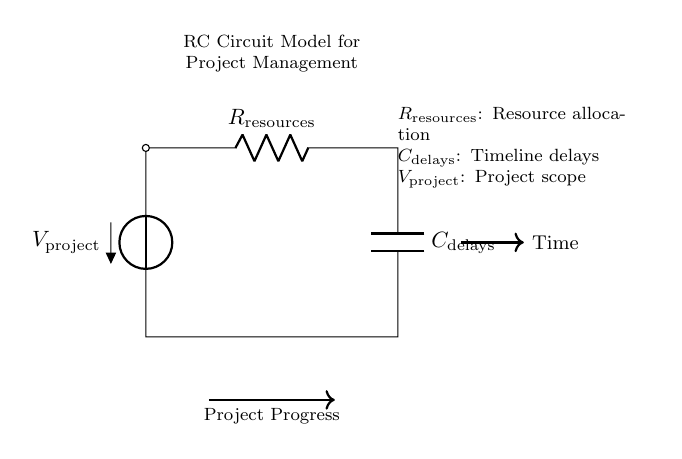What does the resistor represent in this circuit? The resistor represents resource allocation, indicating the amount of resources available for the project.
Answer: Resource allocation What does the capacitor symbolize in the context of project management? The capacitor symbolizes timeline delays, representing the potential delay in project completion due to various factors.
Answer: Timeline delays What is the purpose of the voltage source in the circuit? The voltage source represents the project scope, which is the total amount of work that needs to be completed within the project.
Answer: Project scope If we increase the value of the resistor, what effect does it have on project delays? Increasing the resistor value, or resource allocation, would typically increase the delays since fewer resources would result in slower project progress.
Answer: Increase delays How would you describe the relationship between resource allocation and timeline delays in this model? The relationship is inversely proportional; more resources lead to fewer delays, and fewer resources lead to more delays.
Answer: Inversely proportional What could a short circuit in this model indicate? A short circuit could indicate a failure in resource allocation, leading to zero delays, which is impractical in real project scenarios.
Answer: Failure in resource allocation 